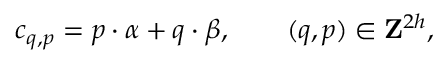Convert formula to latex. <formula><loc_0><loc_0><loc_500><loc_500>c _ { q , p } = { p } \cdot { \alpha } + { q } \cdot { \beta } , \quad ( q , p ) \in { Z } ^ { 2 h } ,</formula> 